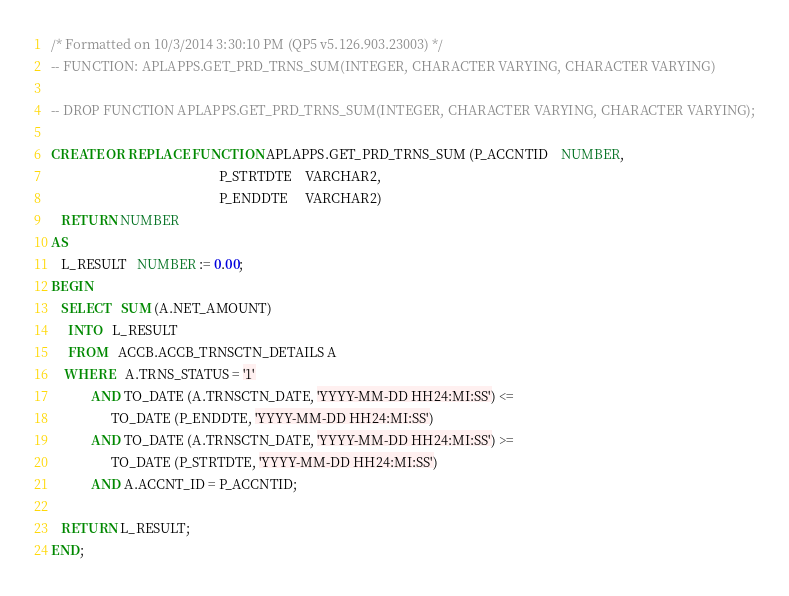Convert code to text. <code><loc_0><loc_0><loc_500><loc_500><_SQL_>/* Formatted on 10/3/2014 3:30:10 PM (QP5 v5.126.903.23003) */
-- FUNCTION: APLAPPS.GET_PRD_TRNS_SUM(INTEGER, CHARACTER VARYING, CHARACTER VARYING)

-- DROP FUNCTION APLAPPS.GET_PRD_TRNS_SUM(INTEGER, CHARACTER VARYING, CHARACTER VARYING);

CREATE OR REPLACE FUNCTION APLAPPS.GET_PRD_TRNS_SUM (P_ACCNTID    NUMBER,
                                                  P_STRTDTE    VARCHAR2,
                                                  P_ENDDTE     VARCHAR2)
   RETURN NUMBER
AS
   L_RESULT   NUMBER := 0.00;
BEGIN
   SELECT   SUM (A.NET_AMOUNT)
     INTO   L_RESULT
     FROM   ACCB.ACCB_TRNSCTN_DETAILS A
    WHERE   A.TRNS_STATUS = '1'
            AND TO_DATE (A.TRNSCTN_DATE, 'YYYY-MM-DD HH24:MI:SS') <=
                  TO_DATE (P_ENDDTE, 'YYYY-MM-DD HH24:MI:SS')
            AND TO_DATE (A.TRNSCTN_DATE, 'YYYY-MM-DD HH24:MI:SS') >=
                  TO_DATE (P_STRTDTE, 'YYYY-MM-DD HH24:MI:SS')
            AND A.ACCNT_ID = P_ACCNTID;

   RETURN L_RESULT;
END;</code> 